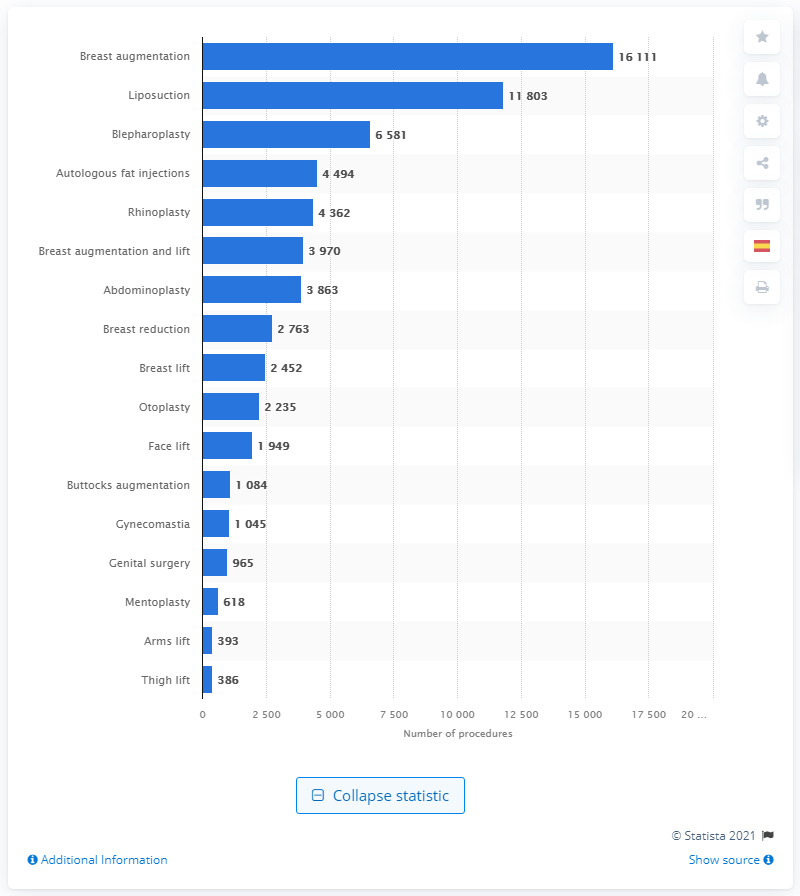Indicate a few pertinent items in this graphic. In 2013, a total of 16,111 breast augmentation procedures were performed in Spain. 